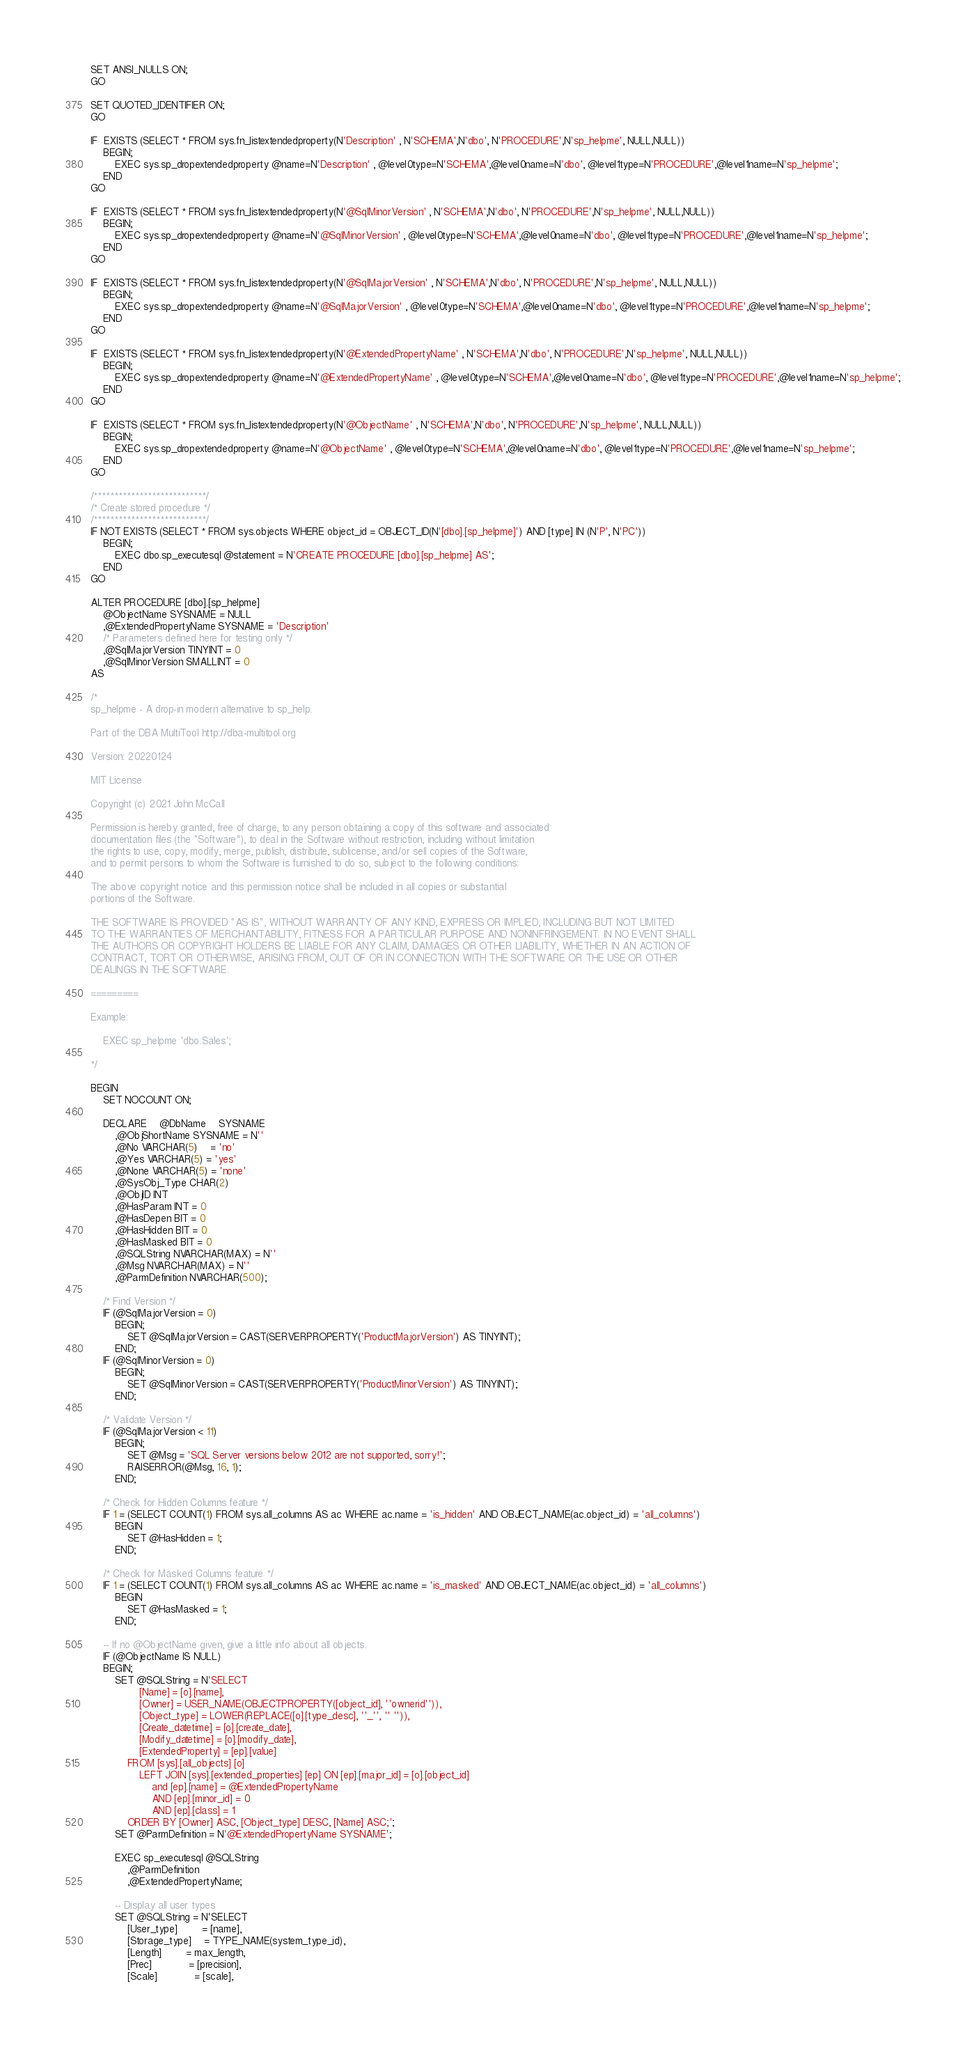Convert code to text. <code><loc_0><loc_0><loc_500><loc_500><_SQL_>SET ANSI_NULLS ON;
GO

SET QUOTED_IDENTIFIER ON;
GO

IF  EXISTS (SELECT * FROM sys.fn_listextendedproperty(N'Description' , N'SCHEMA',N'dbo', N'PROCEDURE',N'sp_helpme', NULL,NULL))
	BEGIN;
		EXEC sys.sp_dropextendedproperty @name=N'Description' , @level0type=N'SCHEMA',@level0name=N'dbo', @level1type=N'PROCEDURE',@level1name=N'sp_helpme';
	END
GO

IF  EXISTS (SELECT * FROM sys.fn_listextendedproperty(N'@SqlMinorVersion' , N'SCHEMA',N'dbo', N'PROCEDURE',N'sp_helpme', NULL,NULL))
	BEGIN;
		EXEC sys.sp_dropextendedproperty @name=N'@SqlMinorVersion' , @level0type=N'SCHEMA',@level0name=N'dbo', @level1type=N'PROCEDURE',@level1name=N'sp_helpme';
	END
GO

IF  EXISTS (SELECT * FROM sys.fn_listextendedproperty(N'@SqlMajorVersion' , N'SCHEMA',N'dbo', N'PROCEDURE',N'sp_helpme', NULL,NULL))
	BEGIN;
		EXEC sys.sp_dropextendedproperty @name=N'@SqlMajorVersion' , @level0type=N'SCHEMA',@level0name=N'dbo', @level1type=N'PROCEDURE',@level1name=N'sp_helpme';
	END
GO

IF  EXISTS (SELECT * FROM sys.fn_listextendedproperty(N'@ExtendedPropertyName' , N'SCHEMA',N'dbo', N'PROCEDURE',N'sp_helpme', NULL,NULL))
	BEGIN;
		EXEC sys.sp_dropextendedproperty @name=N'@ExtendedPropertyName' , @level0type=N'SCHEMA',@level0name=N'dbo', @level1type=N'PROCEDURE',@level1name=N'sp_helpme';
	END
GO

IF  EXISTS (SELECT * FROM sys.fn_listextendedproperty(N'@ObjectName' , N'SCHEMA',N'dbo', N'PROCEDURE',N'sp_helpme', NULL,NULL))
	BEGIN;
		EXEC sys.sp_dropextendedproperty @name=N'@ObjectName' , @level0type=N'SCHEMA',@level0name=N'dbo', @level1type=N'PROCEDURE',@level1name=N'sp_helpme';
	END
GO

/***************************/
/* Create stored procedure */
/***************************/
IF NOT EXISTS (SELECT * FROM sys.objects WHERE object_id = OBJECT_ID(N'[dbo].[sp_helpme]') AND [type] IN (N'P', N'PC'))
	BEGIN;
		EXEC dbo.sp_executesql @statement = N'CREATE PROCEDURE [dbo].[sp_helpme] AS';
	END
GO

ALTER PROCEDURE [dbo].[sp_helpme]
	@ObjectName SYSNAME = NULL
	,@ExtendedPropertyName SYSNAME = 'Description'
	/* Parameters defined here for testing only */
	,@SqlMajorVersion TINYINT = 0
	,@SqlMinorVersion SMALLINT = 0
AS

/*
sp_helpme - A drop-in modern alternative to sp_help.

Part of the DBA MultiTool http://dba-multitool.org

Version: 20220124

MIT License

Copyright (c) 2021 John McCall

Permission is hereby granted, free of charge, to any person obtaining a copy of this software and associated
documentation files (the "Software"), to deal in the Software without restriction, including without limitation
the rights to use, copy, modify, merge, publish, distribute, sublicense, and/or sell copies of the Software,
and to permit persons to whom the Software is furnished to do so, subject to the following conditions:

The above copyright notice and this permission notice shall be included in all copies or substantial
portions of the Software.

THE SOFTWARE IS PROVIDED "AS IS", WITHOUT WARRANTY OF ANY KIND, EXPRESS OR IMPLIED, INCLUDING BUT NOT LIMITED
TO THE WARRANTIES OF MERCHANTABILITY, FITNESS FOR A PARTICULAR PURPOSE AND NONINFRINGEMENT. IN NO EVENT SHALL
THE AUTHORS OR COPYRIGHT HOLDERS BE LIABLE FOR ANY CLAIM, DAMAGES OR OTHER LIABILITY, WHETHER IN AN ACTION OF
CONTRACT, TORT OR OTHERWISE, ARISING FROM, OUT OF OR IN CONNECTION WITH THE SOFTWARE OR THE USE OR OTHER
DEALINGS IN THE SOFTWARE.

=========

Example:

	EXEC sp_helpme 'dbo.Sales';

*/

BEGIN
	SET NOCOUNT ON;

	DECLARE	@DbName	SYSNAME
		,@ObjShortName SYSNAME = N''
		,@No VARCHAR(5)	= 'no'
		,@Yes VARCHAR(5) = 'yes'
		,@None VARCHAR(5) = 'none'
		,@SysObj_Type CHAR(2)
		,@ObjID INT
		,@HasParam INT = 0
		,@HasDepen BIT = 0
		,@HasHidden BIT = 0
		,@HasMasked BIT = 0
		,@SQLString NVARCHAR(MAX) = N''
		,@Msg NVARCHAR(MAX) = N''
		,@ParmDefinition NVARCHAR(500);

	/* Find Version */
	IF (@SqlMajorVersion = 0)
		BEGIN;
			SET @SqlMajorVersion = CAST(SERVERPROPERTY('ProductMajorVersion') AS TINYINT);
		END;
	IF (@SqlMinorVersion = 0)
		BEGIN;
			SET @SqlMinorVersion = CAST(SERVERPROPERTY('ProductMinorVersion') AS TINYINT);
		END;

	/* Validate Version */
	IF (@SqlMajorVersion < 11)
		BEGIN;
			SET @Msg = 'SQL Server versions below 2012 are not supported, sorry!';
			RAISERROR(@Msg, 16, 1);
		END;

	/* Check for Hidden Columns feature */
	IF 1 = (SELECT COUNT(1) FROM sys.all_columns AS ac WHERE ac.name = 'is_hidden' AND OBJECT_NAME(ac.object_id) = 'all_columns')
		BEGIN
			SET @HasHidden = 1;
		END;

	/* Check for Masked Columns feature */
	IF 1 = (SELECT COUNT(1) FROM sys.all_columns AS ac WHERE ac.name = 'is_masked' AND OBJECT_NAME(ac.object_id) = 'all_columns')
		BEGIN
			SET @HasMasked = 1;
		END;

	-- If no @ObjectName given, give a little info about all objects.
	IF (@ObjectName IS NULL)
	BEGIN;
		SET @SQLString = N'SELECT
				[Name] = [o].[name],
				[Owner] = USER_NAME(OBJECTPROPERTY([object_id], ''ownerid'')),
				[Object_type] = LOWER(REPLACE([o].[type_desc], ''_'', '' '')),
				[Create_datetime] = [o].[create_date],
				[Modify_datetime] = [o].[modify_date],
				[ExtendedProperty] = [ep].[value]
			FROM [sys].[all_objects] [o]
				LEFT JOIN [sys].[extended_properties] [ep] ON [ep].[major_id] = [o].[object_id]
					and [ep].[name] = @ExtendedPropertyName
					AND [ep].[minor_id] = 0
					AND [ep].[class] = 1
			ORDER BY [Owner] ASC, [Object_type] DESC, [Name] ASC;';
		SET @ParmDefinition = N'@ExtendedPropertyName SYSNAME';

		EXEC sp_executesql @SQLString
			,@ParmDefinition
			,@ExtendedPropertyName;

		-- Display all user types
		SET @SQLString = N'SELECT
			[User_type]		= [name],
			[Storage_type]	= TYPE_NAME(system_type_id),
			[Length]		= max_length,
			[Prec]			= [precision],
			[Scale]			= [scale],</code> 